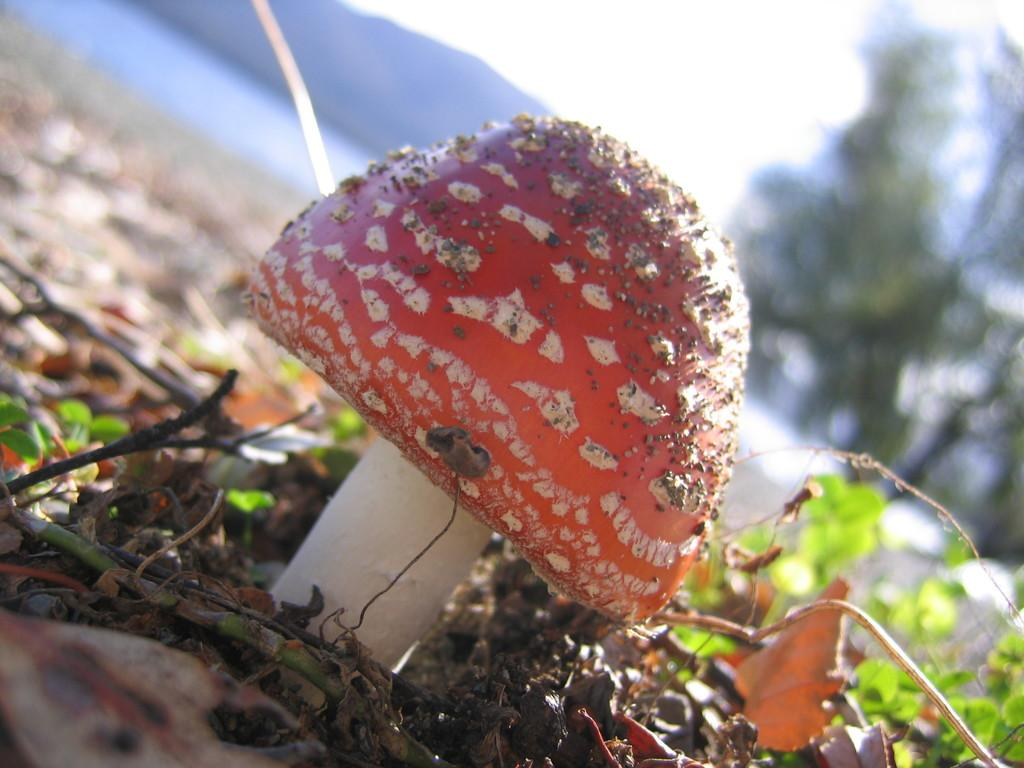What is the main subject of the image? There is a mushroom in the image. What other elements can be seen in the image? There are stems and leaves visible in the image. Can you describe the background of the image? The background of the image is blurred, and there is a mountain, trees, and the sky visible. What type of straw is being used to create the ghostly figure in the image? There is no straw or ghostly figure present in the image. What material is the brass used for in the image? There is no brass present in the image. 